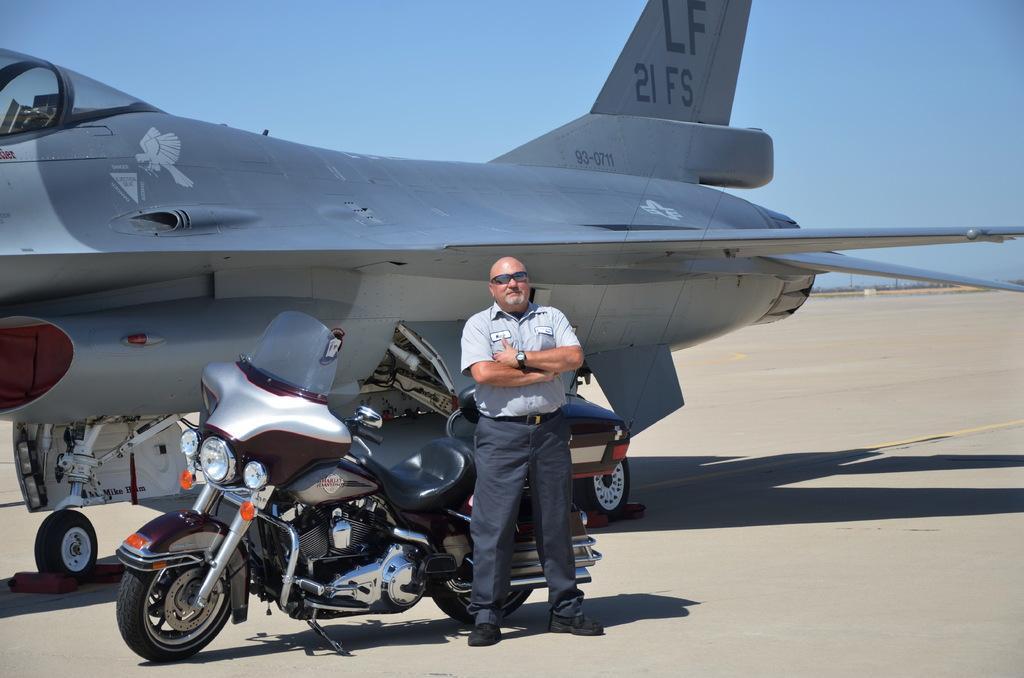Describe this image in one or two sentences. In this image I can see a man is standing and I can see he is wearing shirt, pant, shoes, watch and shades. In the background I can see motorcycle, an aircraft, shadows and the sky. I can also see something is written over here. 